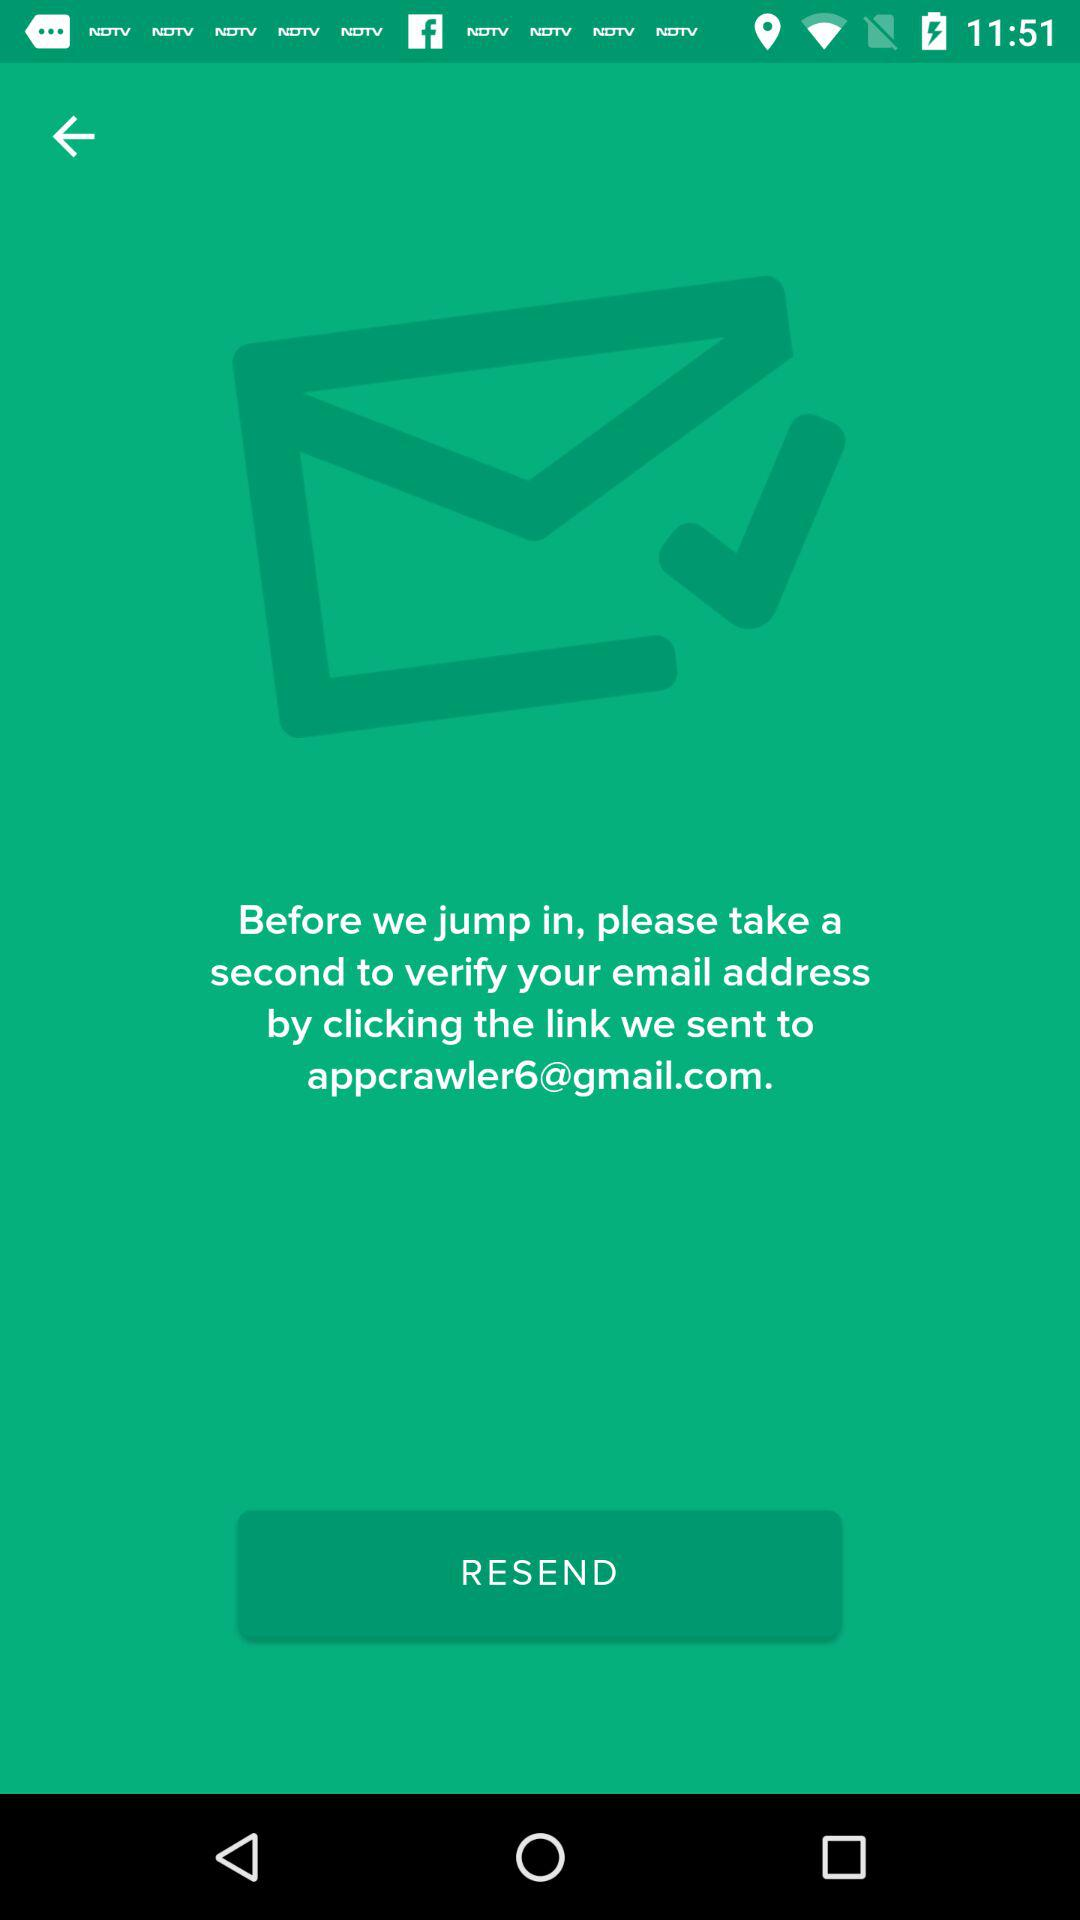What is the email address? The email address is appcrawler6@gmail.com. 